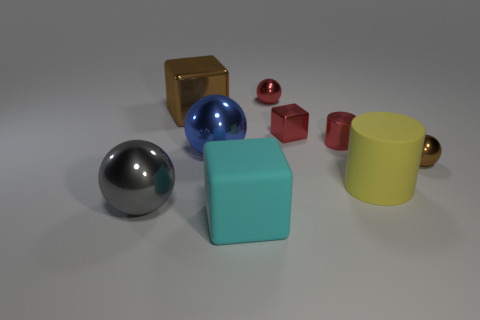Can you describe the size and color of the sphere that seems to catch most of the light? Certainly! The sphere that catches most of the light is large and has a glossy silver surface. Its reflective quality makes it stand out against the matte background, highlighting the contrast in textures. 